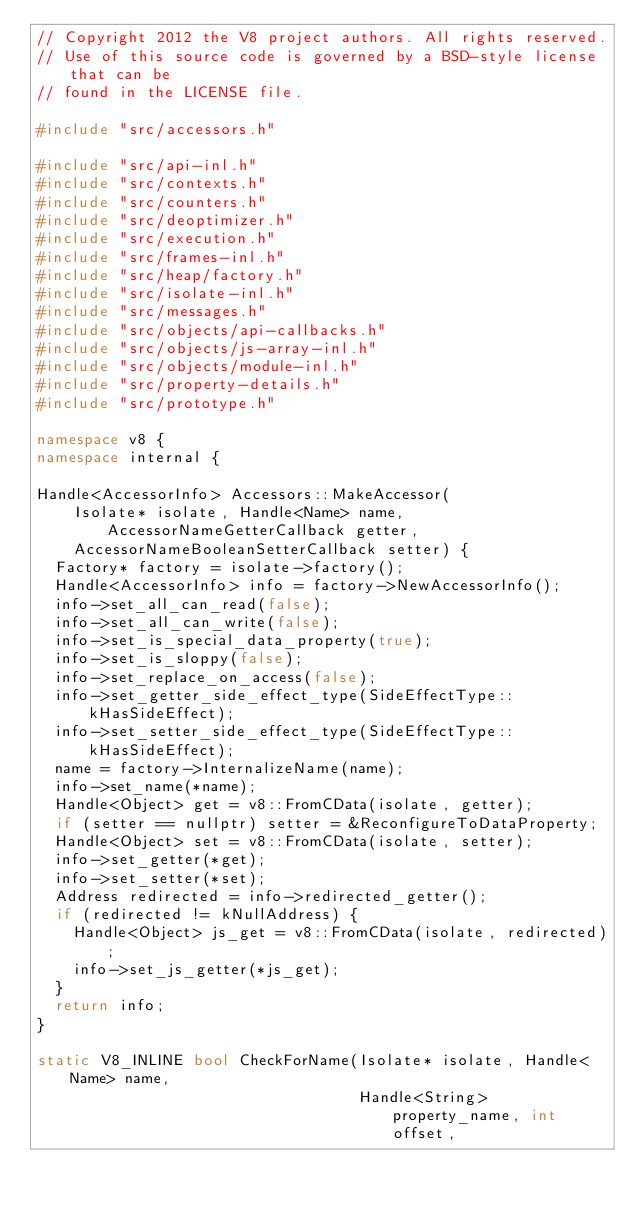<code> <loc_0><loc_0><loc_500><loc_500><_C++_>// Copyright 2012 the V8 project authors. All rights reserved.
// Use of this source code is governed by a BSD-style license that can be
// found in the LICENSE file.

#include "src/accessors.h"

#include "src/api-inl.h"
#include "src/contexts.h"
#include "src/counters.h"
#include "src/deoptimizer.h"
#include "src/execution.h"
#include "src/frames-inl.h"
#include "src/heap/factory.h"
#include "src/isolate-inl.h"
#include "src/messages.h"
#include "src/objects/api-callbacks.h"
#include "src/objects/js-array-inl.h"
#include "src/objects/module-inl.h"
#include "src/property-details.h"
#include "src/prototype.h"

namespace v8 {
namespace internal {

Handle<AccessorInfo> Accessors::MakeAccessor(
    Isolate* isolate, Handle<Name> name, AccessorNameGetterCallback getter,
    AccessorNameBooleanSetterCallback setter) {
  Factory* factory = isolate->factory();
  Handle<AccessorInfo> info = factory->NewAccessorInfo();
  info->set_all_can_read(false);
  info->set_all_can_write(false);
  info->set_is_special_data_property(true);
  info->set_is_sloppy(false);
  info->set_replace_on_access(false);
  info->set_getter_side_effect_type(SideEffectType::kHasSideEffect);
  info->set_setter_side_effect_type(SideEffectType::kHasSideEffect);
  name = factory->InternalizeName(name);
  info->set_name(*name);
  Handle<Object> get = v8::FromCData(isolate, getter);
  if (setter == nullptr) setter = &ReconfigureToDataProperty;
  Handle<Object> set = v8::FromCData(isolate, setter);
  info->set_getter(*get);
  info->set_setter(*set);
  Address redirected = info->redirected_getter();
  if (redirected != kNullAddress) {
    Handle<Object> js_get = v8::FromCData(isolate, redirected);
    info->set_js_getter(*js_get);
  }
  return info;
}

static V8_INLINE bool CheckForName(Isolate* isolate, Handle<Name> name,
                                   Handle<String> property_name, int offset,</code> 